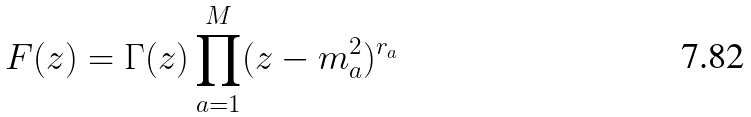<formula> <loc_0><loc_0><loc_500><loc_500>F ( z ) = \Gamma ( z ) \prod _ { a = 1 } ^ { M } ( z - m _ { a } ^ { 2 } ) ^ { r _ { a } }</formula> 